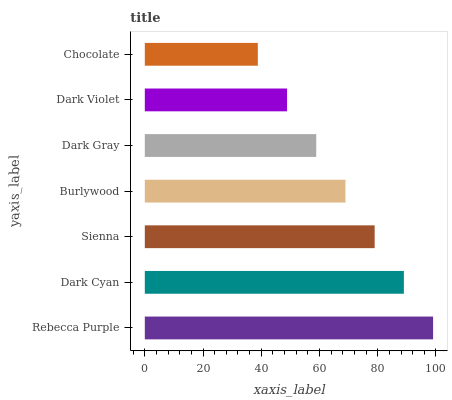Is Chocolate the minimum?
Answer yes or no. Yes. Is Rebecca Purple the maximum?
Answer yes or no. Yes. Is Dark Cyan the minimum?
Answer yes or no. No. Is Dark Cyan the maximum?
Answer yes or no. No. Is Rebecca Purple greater than Dark Cyan?
Answer yes or no. Yes. Is Dark Cyan less than Rebecca Purple?
Answer yes or no. Yes. Is Dark Cyan greater than Rebecca Purple?
Answer yes or no. No. Is Rebecca Purple less than Dark Cyan?
Answer yes or no. No. Is Burlywood the high median?
Answer yes or no. Yes. Is Burlywood the low median?
Answer yes or no. Yes. Is Rebecca Purple the high median?
Answer yes or no. No. Is Dark Violet the low median?
Answer yes or no. No. 